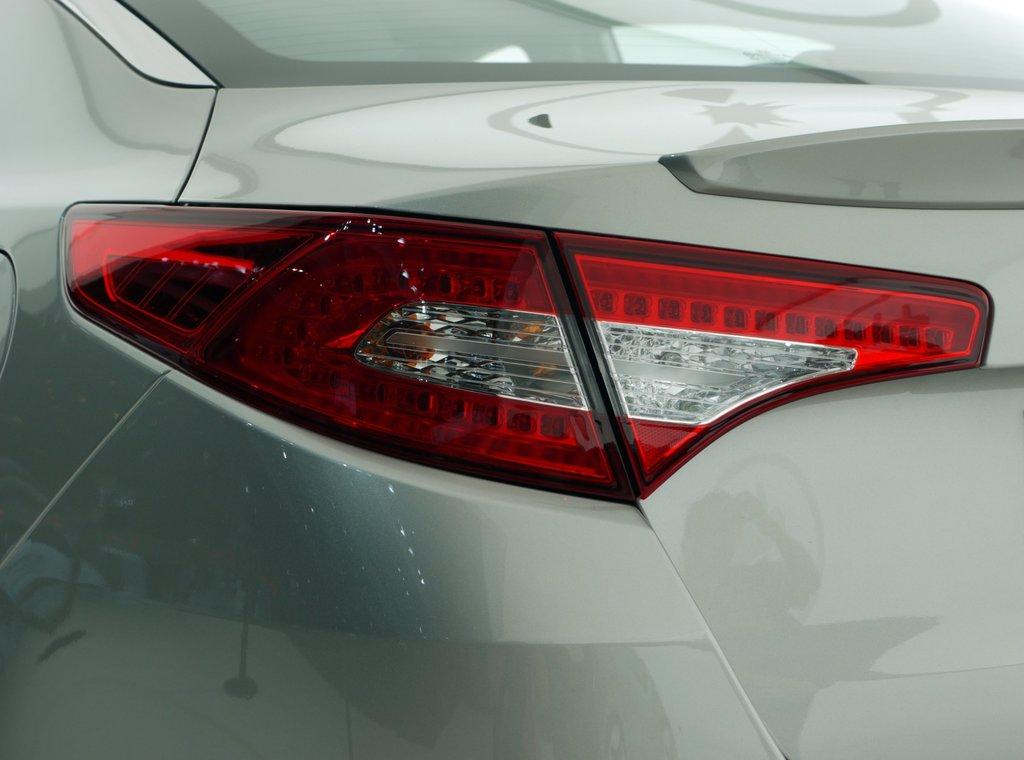What type of vehicle is partially visible in the image? There is a partial part of a car in the image. What specific feature of the car can be seen in the image? A brake light is visible in the image. What type of pen is being used to sign a business contract in the image? There is no pen or business contract present in the image; it only features a partial part of a car and a brake light. 